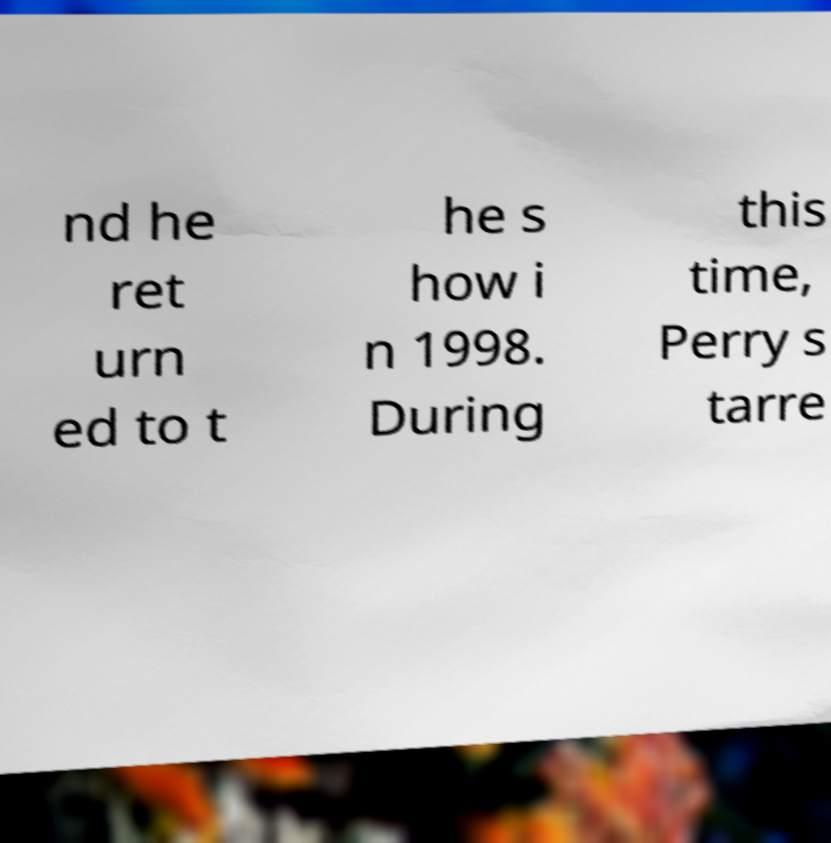Please identify and transcribe the text found in this image. nd he ret urn ed to t he s how i n 1998. During this time, Perry s tarre 